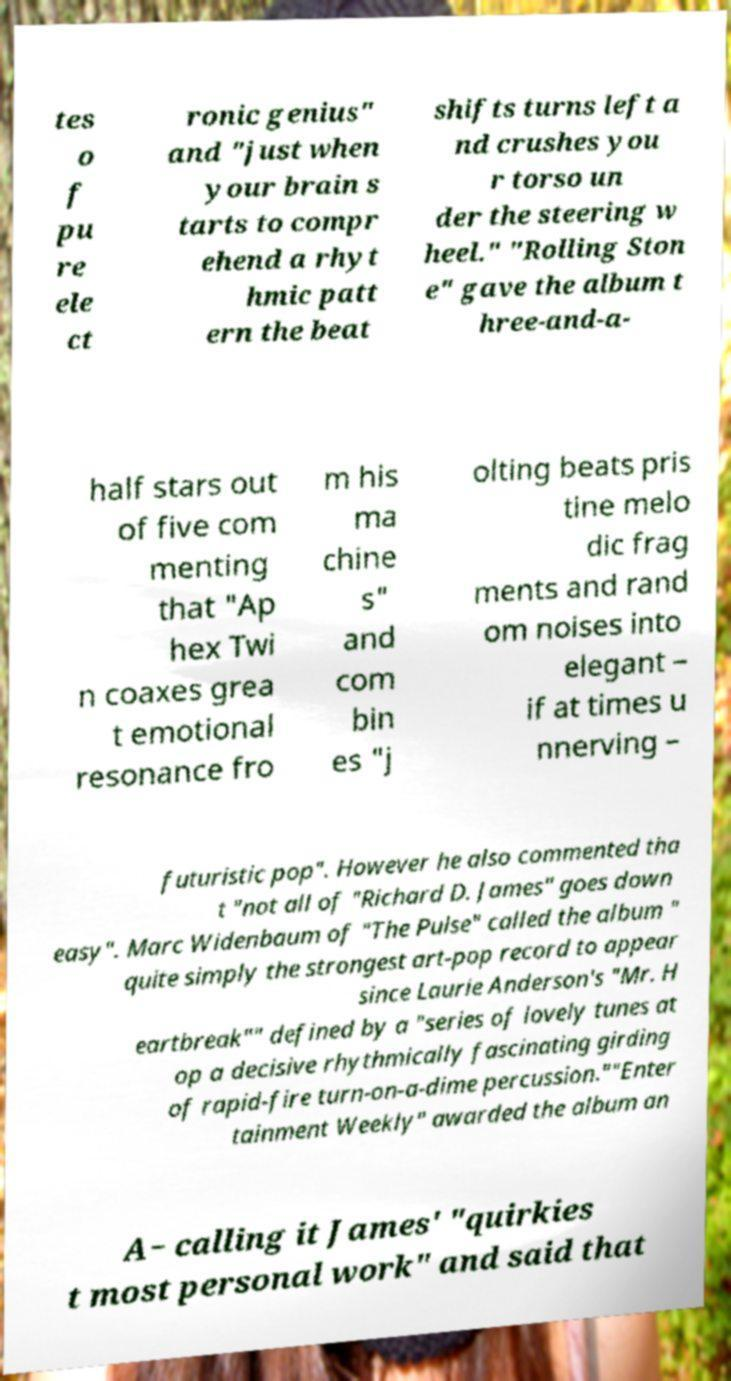Could you extract and type out the text from this image? tes o f pu re ele ct ronic genius" and "just when your brain s tarts to compr ehend a rhyt hmic patt ern the beat shifts turns left a nd crushes you r torso un der the steering w heel." "Rolling Ston e" gave the album t hree-and-a- half stars out of five com menting that "Ap hex Twi n coaxes grea t emotional resonance fro m his ma chine s" and com bin es "j olting beats pris tine melo dic frag ments and rand om noises into elegant – if at times u nnerving – futuristic pop". However he also commented tha t "not all of "Richard D. James" goes down easy". Marc Widenbaum of "The Pulse" called the album " quite simply the strongest art-pop record to appear since Laurie Anderson's "Mr. H eartbreak"" defined by a "series of lovely tunes at op a decisive rhythmically fascinating girding of rapid-fire turn-on-a-dime percussion.""Enter tainment Weekly" awarded the album an A− calling it James' "quirkies t most personal work" and said that 